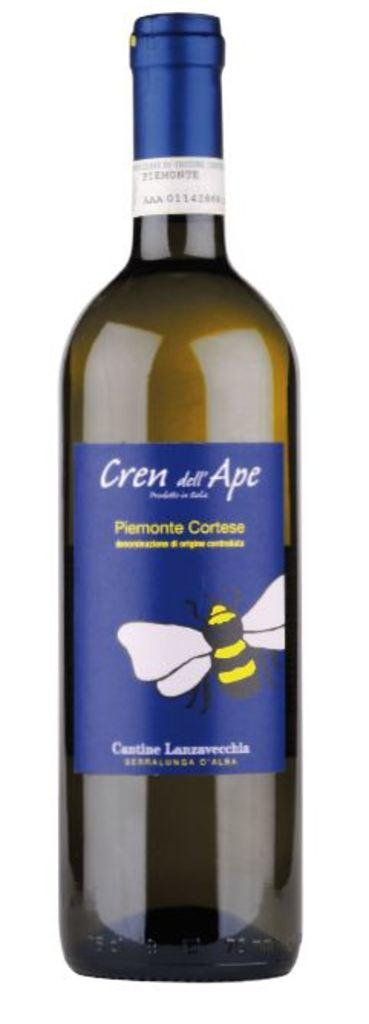<image>
Describe the image concisely. A bottle of Cren dell Ape stands alone. 